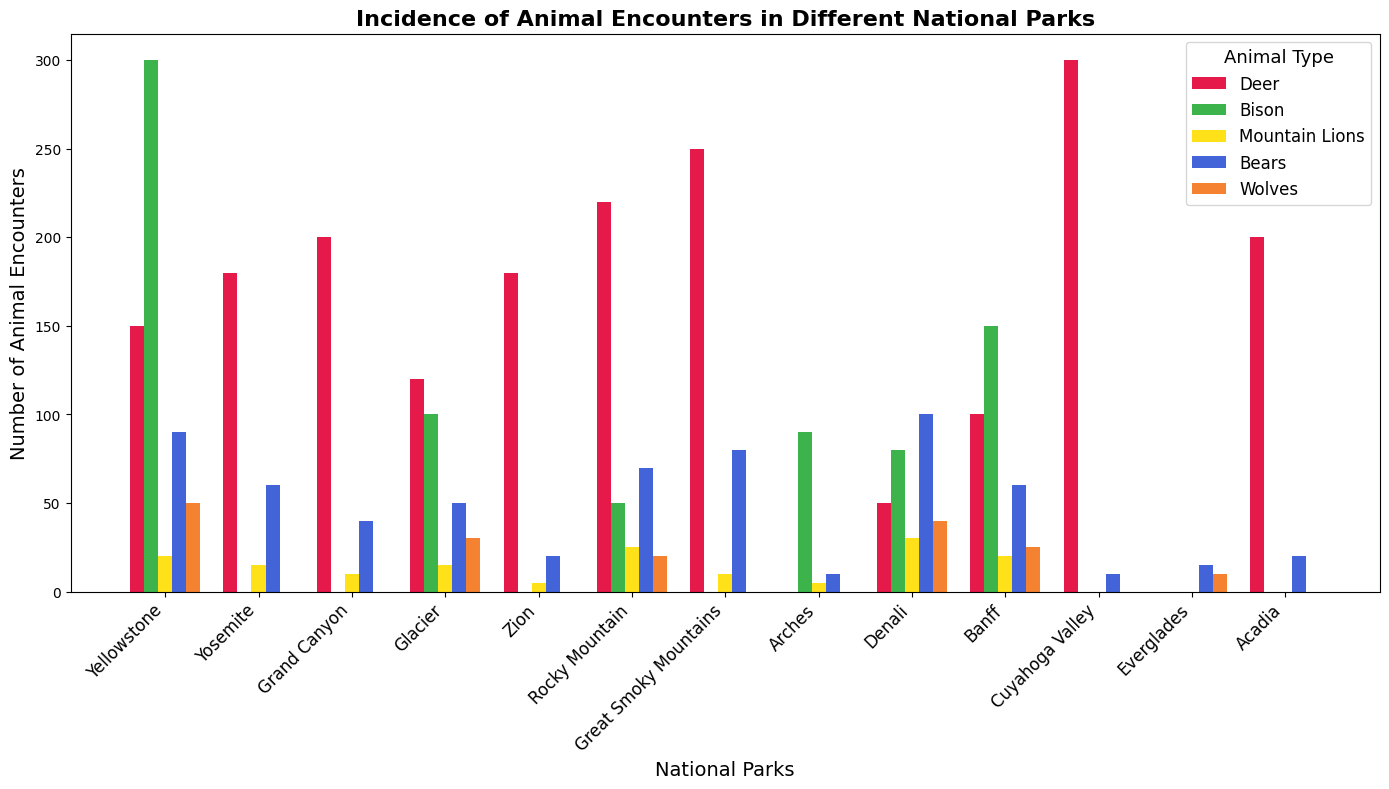How many more deer encounters are reported in the Great Smoky Mountains compared to Denali? Look at the height of the bars for deer encounters in the Great Smoky Mountains and Denali. Subtract the number in Denali (50) from the number in Great Smoky Mountains (250).
Answer: 200 Which national park has the highest total number of animal encounters across all types? Sum the heights of all the bars for each national park. Cuyahoga Valley has a single high bar for deer encounters (300), which is higher than the sum of any other park's encounters.
Answer: Cuyahoga Valley Is the total number of mountain lion encounters in Yellowstone and Glacier greater than that in Denali and Banff combined? Sum the mountain lion encounters in Yellowstone (20) and Glacier (15) to get 35. Then, sum the mountain lion encounters in Denali (30) and Banff (20) to get 50. Compare the two sums: 35 < 50.
Answer: No Which color represents bear encounters? Identify the bar color for bear encounters in any park. For example, look at the Great Smoky Mountains, which has a middle-height bar for bears in orange.
Answer: Orange In how many parks are there no encounters with wolves? Count the national parks where the bar height for wolves is zero. These parks are Yosemite, Grand Canyon, Zion, Rocky Mountain, Great Smoky Mountains, Arches, Cuyahoga Valley, and Acadia, making 8 parks in total.
Answer: 8 